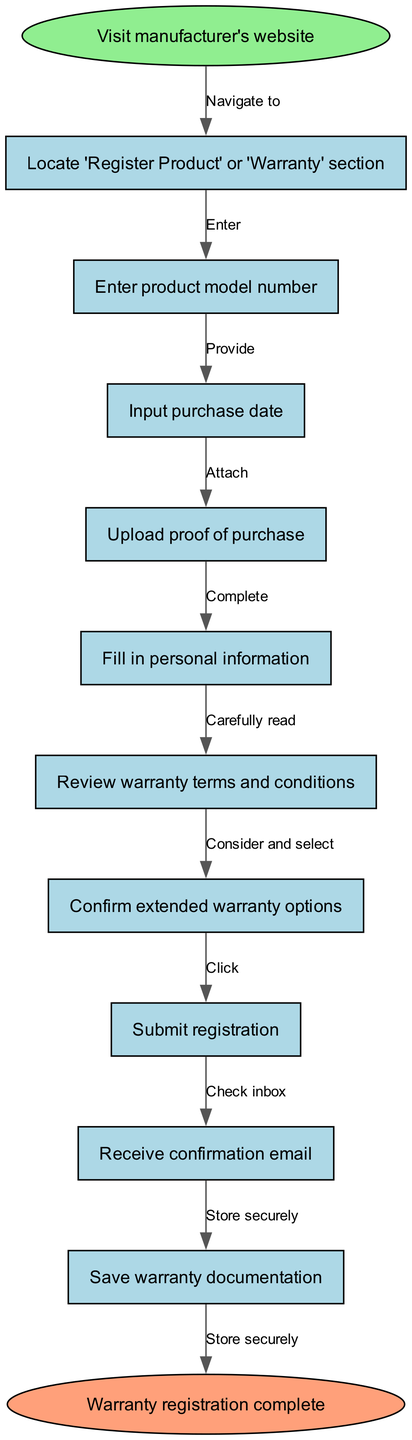What is the starting point of the flowchart? The starting point, indicated as 'start', is the first action in the flowchart, which instructs the user to "Visit manufacturer's website".
Answer: Visit manufacturer's website How many nodes are present in this flowchart? The flowchart contains a total of 10 nodes, including the start and end nodes. Counting all the steps listed in the nodes section gives 10.
Answer: 10 What is the last action before submission? The last action before submission is "Consider and select" which relates to reviewing the extended warranty options.
Answer: Consider and select What section should be located after entering the purchase date? After entering the purchase date, the next section to locate is "Upload proof of purchase", which continues the registration process.
Answer: Upload proof of purchase What is the final confirmation step in this flowchart? The final confirmation step is represented by the end node, which states "Warranty registration complete".
Answer: Warranty registration complete What relationship exists between "Enter product model number" and "Input purchase date"? There is a sequential relationship; first, you "Enter product model number", and then you proceed to "Input purchase date", meaning "Input purchase date" follows "Enter product model number".
Answer: Input purchase date follows At what point do you receive confirmation? "Check inbox" is the point where you receive confirmation, specifically after submitting your registration.
Answer: Check inbox What is the edge type connected to the last action? The edge type connecting to the last action "Submit registration" is "Click", indicating an action that the user must take.
Answer: Click Which node requires reading warranty terms and conditions? The node that requires this action is "Review warranty terms and conditions", and it follows the input of personal information.
Answer: Review warranty terms and conditions 